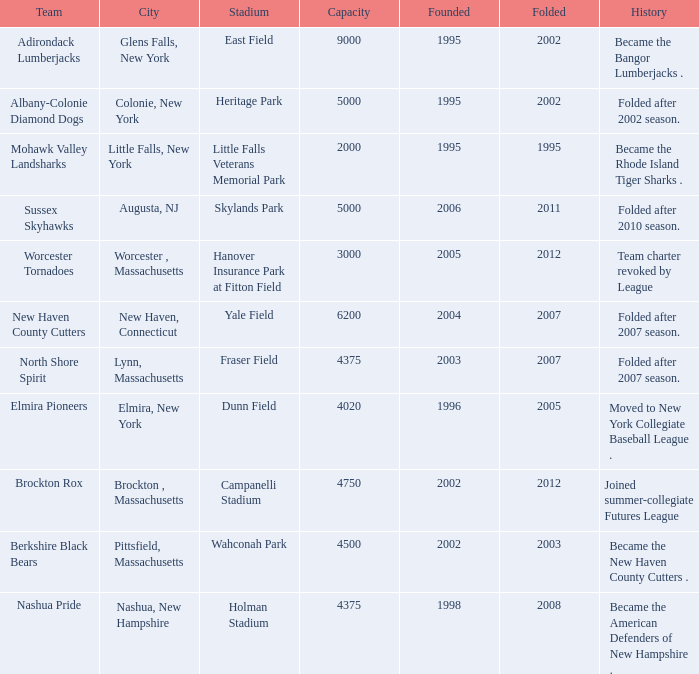What is the maximum founded year of the Worcester Tornadoes? 2005.0. 